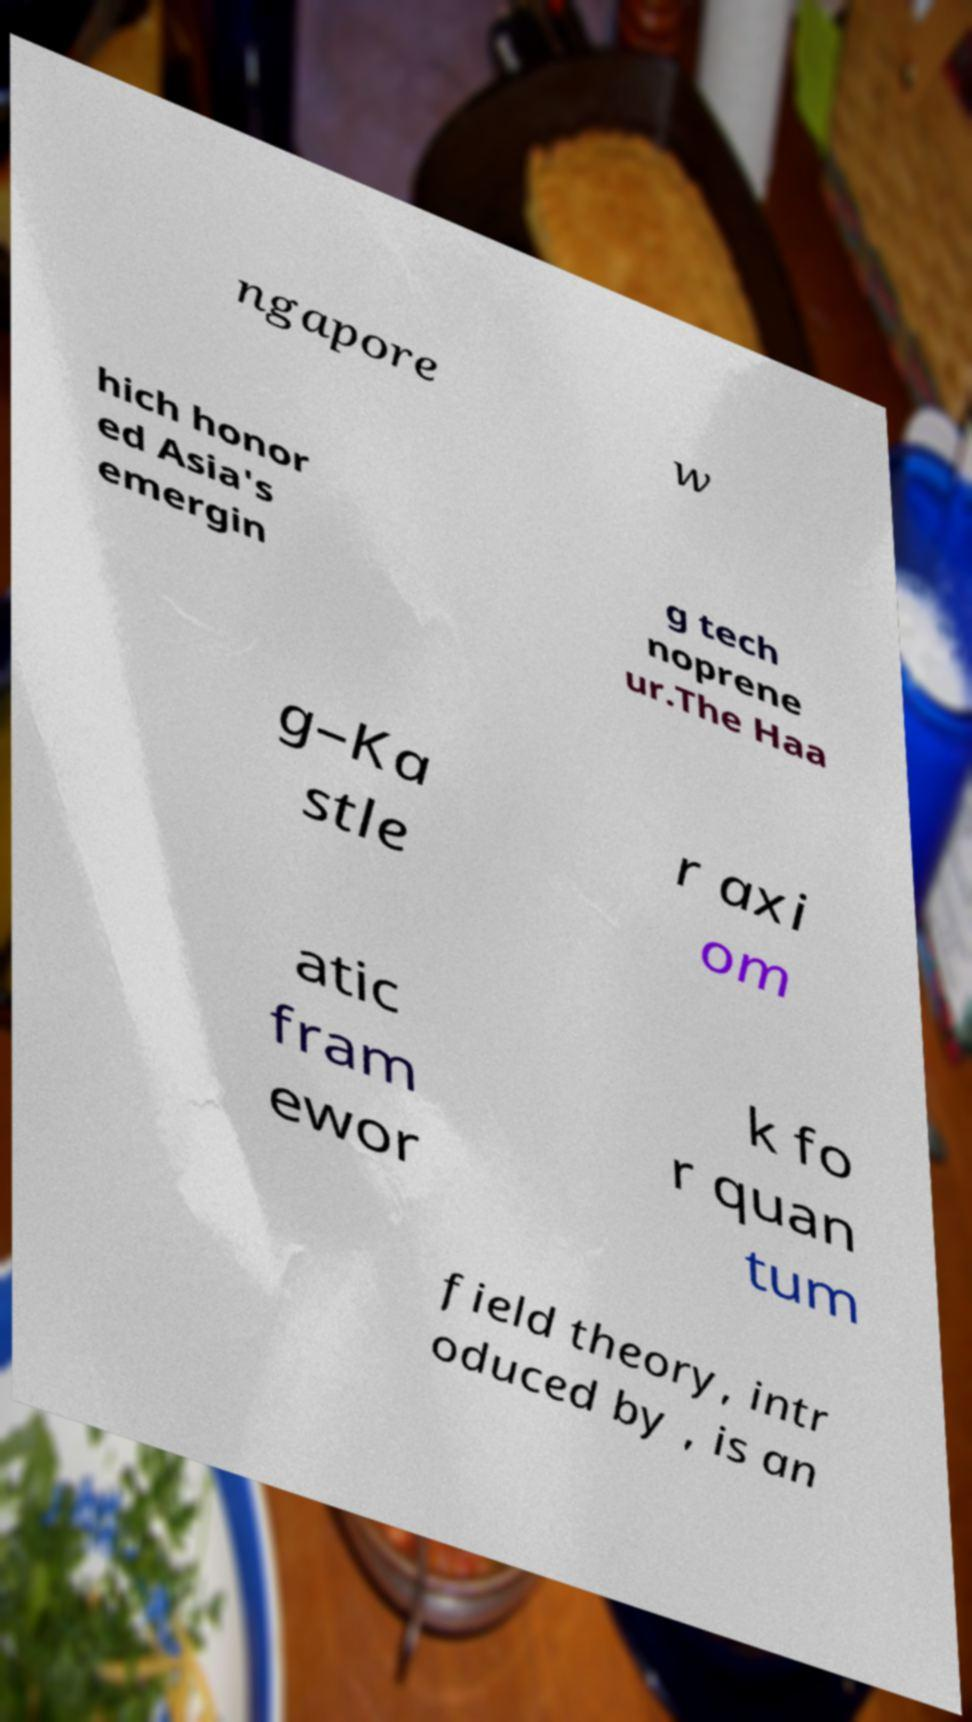Can you read and provide the text displayed in the image?This photo seems to have some interesting text. Can you extract and type it out for me? ngapore w hich honor ed Asia's emergin g tech noprene ur.The Haa g–Ka stle r axi om atic fram ewor k fo r quan tum field theory, intr oduced by , is an 